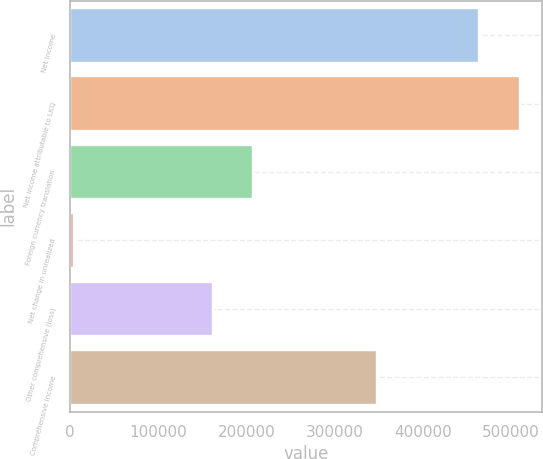<chart> <loc_0><loc_0><loc_500><loc_500><bar_chart><fcel>Net income<fcel>Net income attributable to LKQ<fcel>Foreign currency translation<fcel>Net change in unrealized<fcel>Other comprehensive (loss)<fcel>Comprehensive income<nl><fcel>463975<fcel>509881<fcel>207611<fcel>4911<fcel>161705<fcel>348176<nl></chart> 